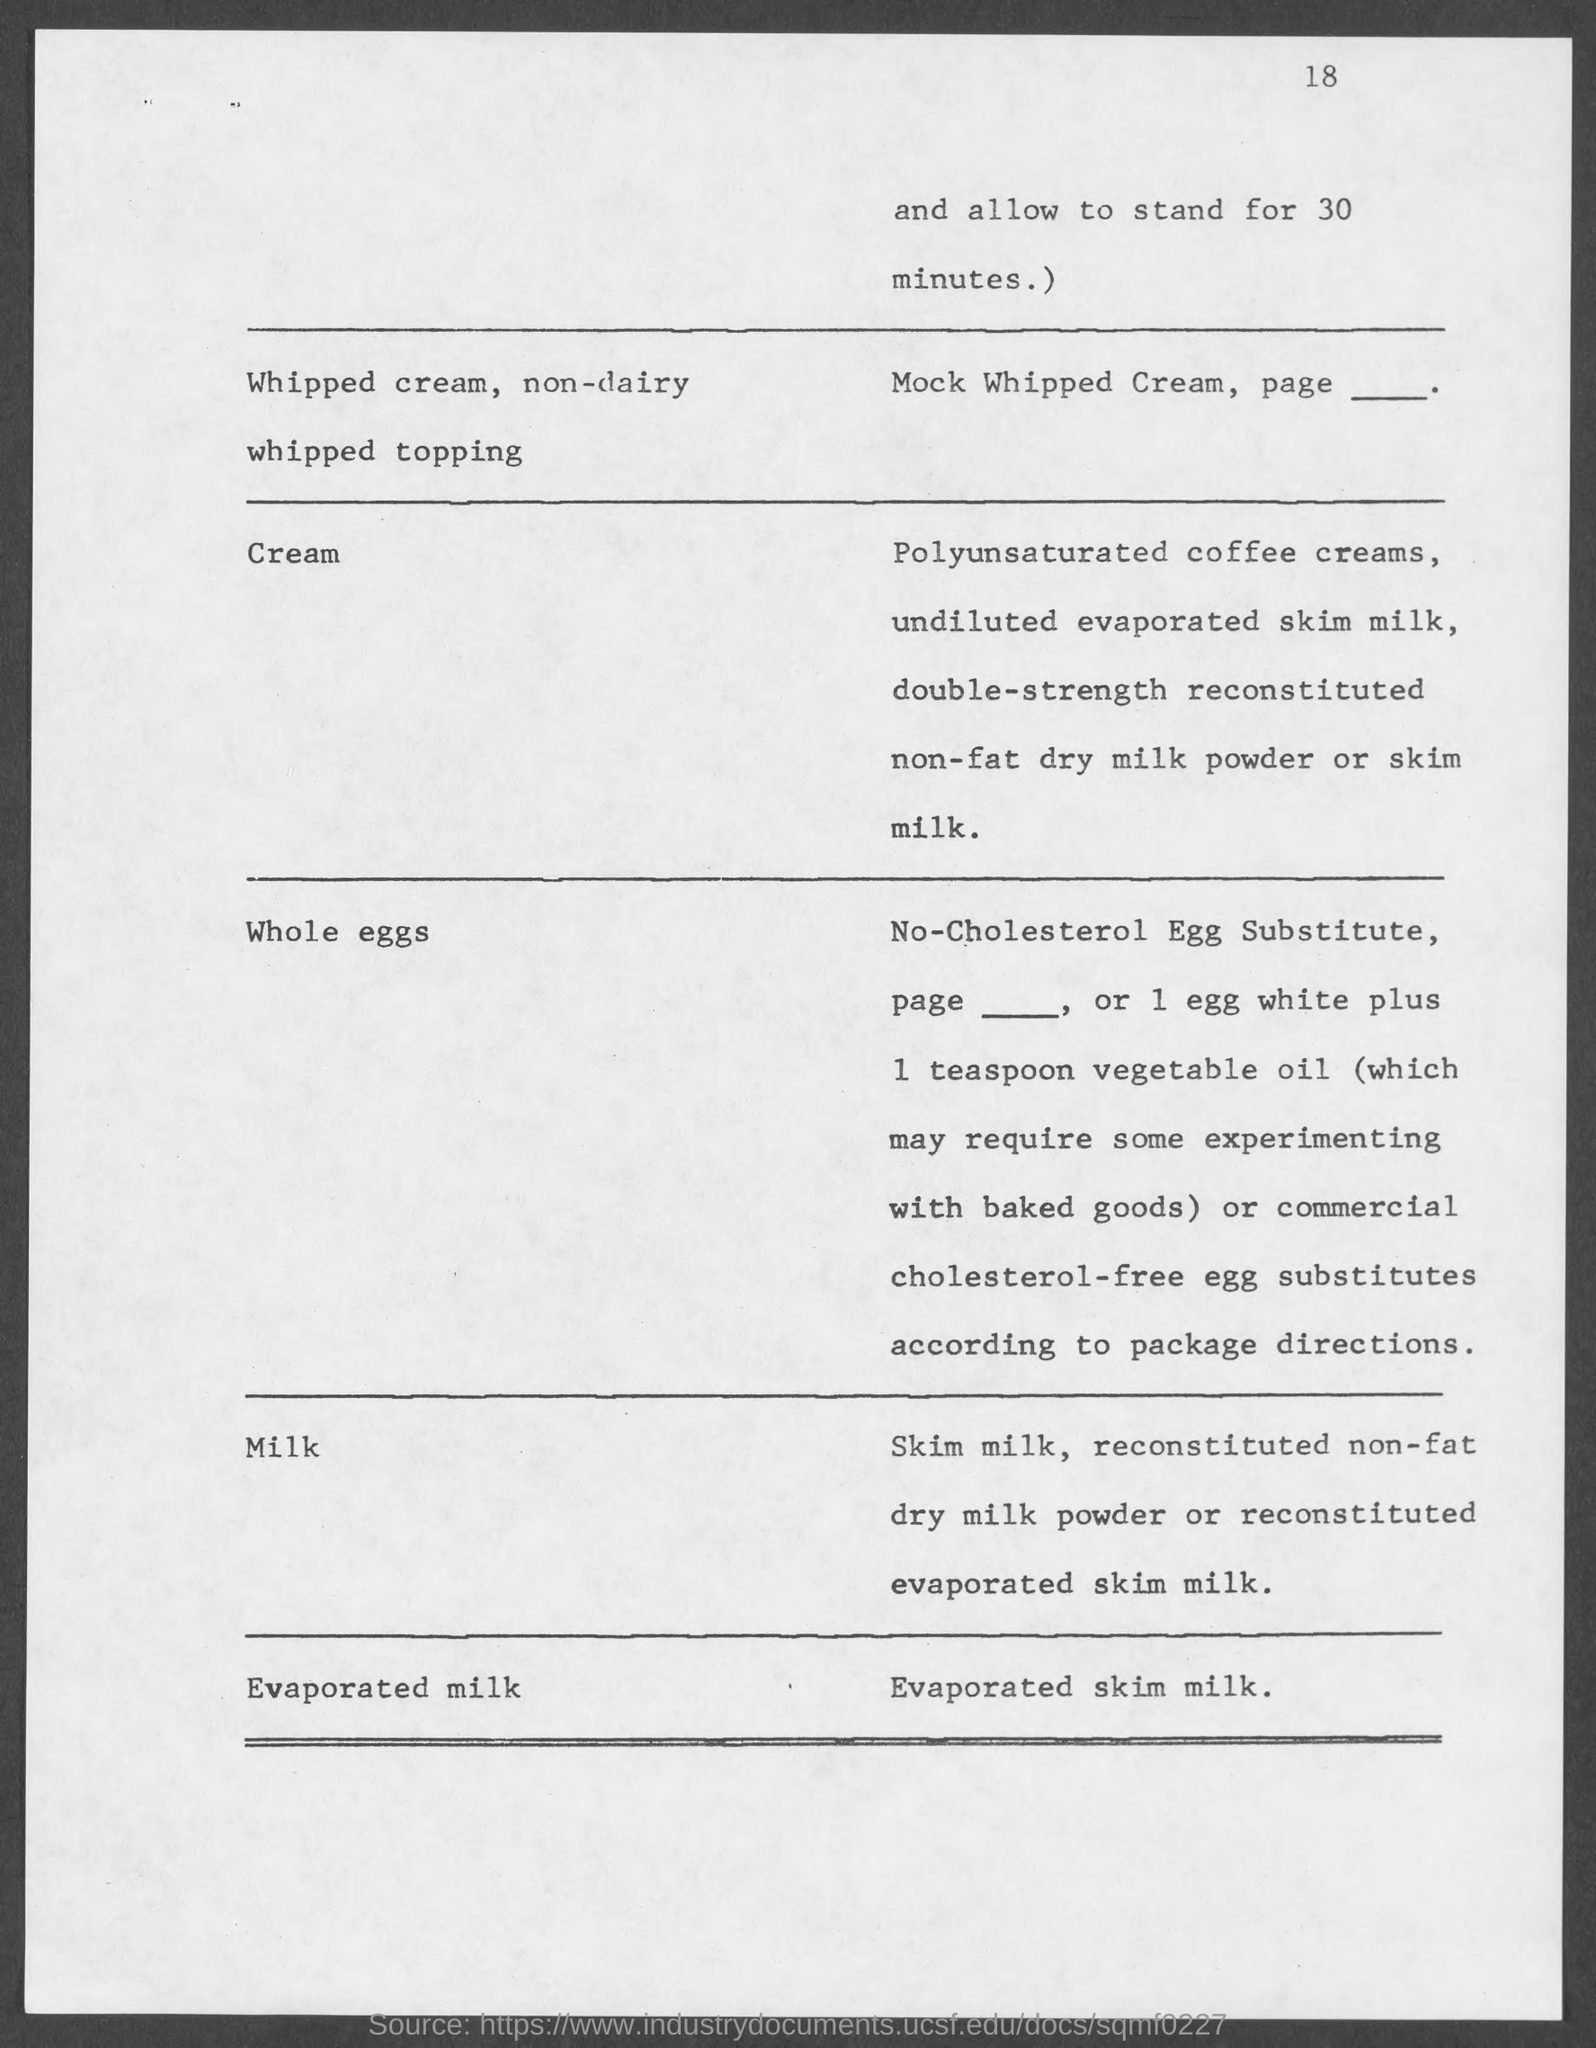What is the number at top-right corner of the page?
Your response must be concise. 18. 